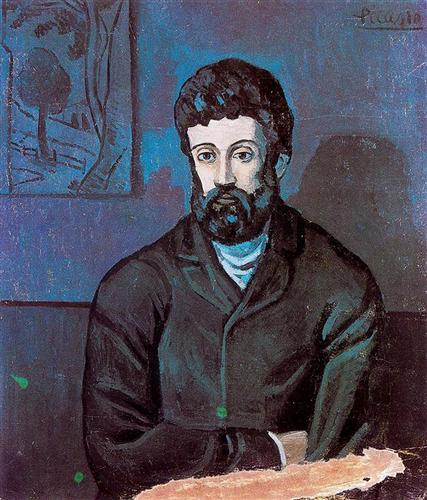Describe the following image. The image depicts a striking portrait of a bearded man with thoughtful eyes, dressed in a dark jacket over a blue shirt. The portrait is set against a stark blue background, which is skilfully contrasted with a subtle green tree sketch on the left, suggesting a connection to nature amidst personal contemplation. The style, characterized by flat, vivid planes of color, suggests influence from early 20th-century avant-garde movements, likely synthesizing elements from both post-impressionism and expressionism. However, the artwork is incorrectly attributed to Picasso in the previous response; it would be advantageous to verify the artist and explore the emotional and thematic depth of the portrait more comprehensively. 